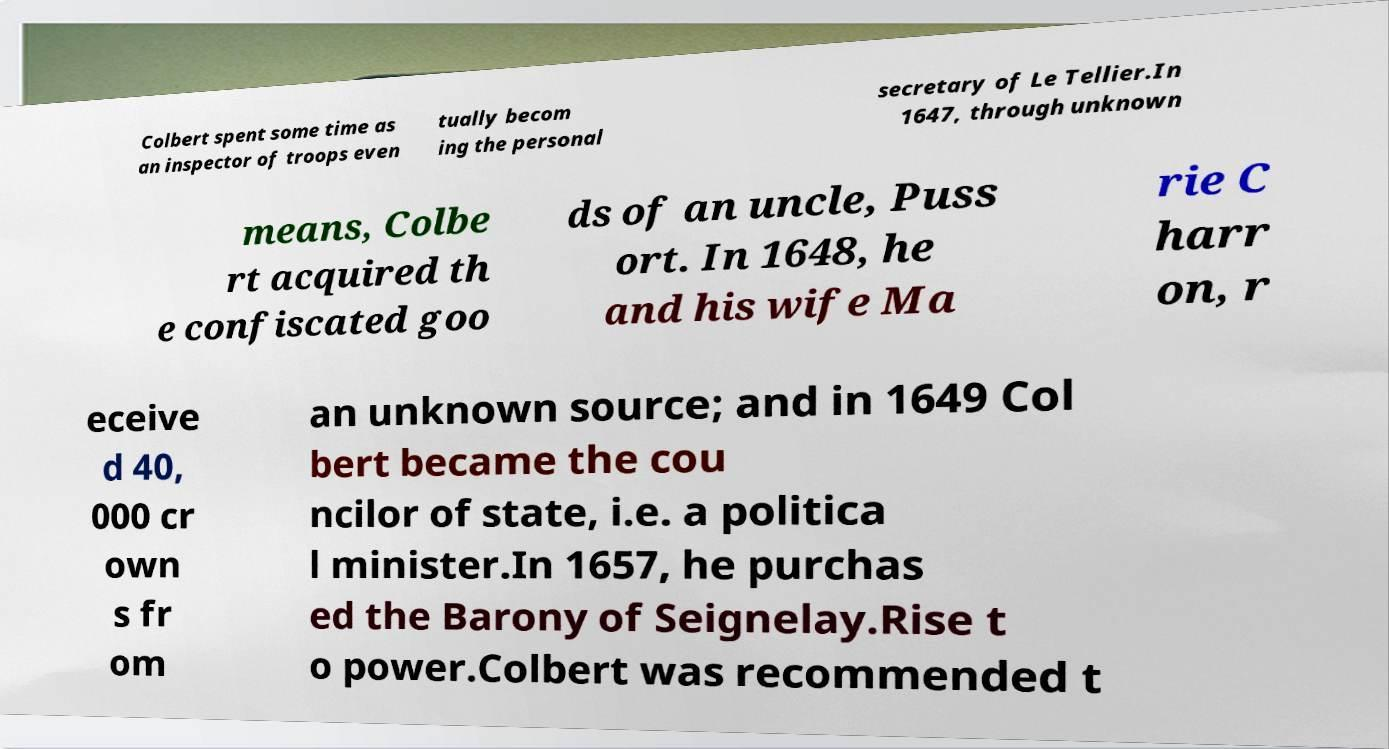Please read and relay the text visible in this image. What does it say? Colbert spent some time as an inspector of troops even tually becom ing the personal secretary of Le Tellier.In 1647, through unknown means, Colbe rt acquired th e confiscated goo ds of an uncle, Puss ort. In 1648, he and his wife Ma rie C harr on, r eceive d 40, 000 cr own s fr om an unknown source; and in 1649 Col bert became the cou ncilor of state, i.e. a politica l minister.In 1657, he purchas ed the Barony of Seignelay.Rise t o power.Colbert was recommended t 